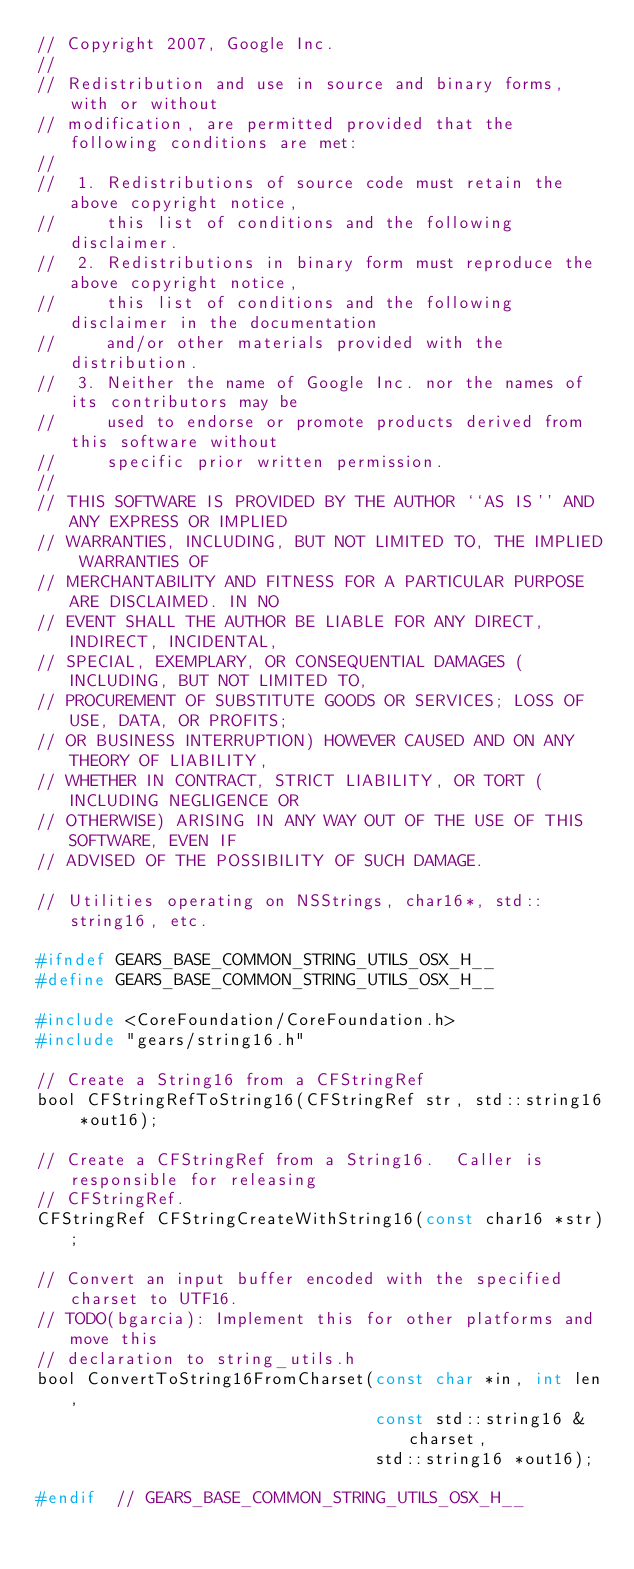Convert code to text. <code><loc_0><loc_0><loc_500><loc_500><_C_>// Copyright 2007, Google Inc.
//
// Redistribution and use in source and binary forms, with or without 
// modification, are permitted provided that the following conditions are met:
//
//  1. Redistributions of source code must retain the above copyright notice, 
//     this list of conditions and the following disclaimer.
//  2. Redistributions in binary form must reproduce the above copyright notice,
//     this list of conditions and the following disclaimer in the documentation
//     and/or other materials provided with the distribution.
//  3. Neither the name of Google Inc. nor the names of its contributors may be
//     used to endorse or promote products derived from this software without
//     specific prior written permission.
//
// THIS SOFTWARE IS PROVIDED BY THE AUTHOR ``AS IS'' AND ANY EXPRESS OR IMPLIED
// WARRANTIES, INCLUDING, BUT NOT LIMITED TO, THE IMPLIED WARRANTIES OF 
// MERCHANTABILITY AND FITNESS FOR A PARTICULAR PURPOSE ARE DISCLAIMED. IN NO
// EVENT SHALL THE AUTHOR BE LIABLE FOR ANY DIRECT, INDIRECT, INCIDENTAL, 
// SPECIAL, EXEMPLARY, OR CONSEQUENTIAL DAMAGES (INCLUDING, BUT NOT LIMITED TO,
// PROCUREMENT OF SUBSTITUTE GOODS OR SERVICES; LOSS OF USE, DATA, OR PROFITS;
// OR BUSINESS INTERRUPTION) HOWEVER CAUSED AND ON ANY THEORY OF LIABILITY,
// WHETHER IN CONTRACT, STRICT LIABILITY, OR TORT (INCLUDING NEGLIGENCE OR 
// OTHERWISE) ARISING IN ANY WAY OUT OF THE USE OF THIS SOFTWARE, EVEN IF 
// ADVISED OF THE POSSIBILITY OF SUCH DAMAGE.

// Utilities operating on NSStrings, char16*, std::string16, etc.

#ifndef GEARS_BASE_COMMON_STRING_UTILS_OSX_H__
#define GEARS_BASE_COMMON_STRING_UTILS_OSX_H__

#include <CoreFoundation/CoreFoundation.h>
#include "gears/string16.h"

// Create a String16 from a CFStringRef
bool CFStringRefToString16(CFStringRef str, std::string16 *out16);

// Create a CFStringRef from a String16.  Caller is responsible for releasing
// CFStringRef.
CFStringRef CFStringCreateWithString16(const char16 *str);

// Convert an input buffer encoded with the specified charset to UTF16.
// TODO(bgarcia): Implement this for other platforms and move this
// declaration to string_utils.h
bool ConvertToString16FromCharset(const char *in, int len,
                                  const std::string16 &charset,
                                  std::string16 *out16);

#endif  // GEARS_BASE_COMMON_STRING_UTILS_OSX_H__
</code> 